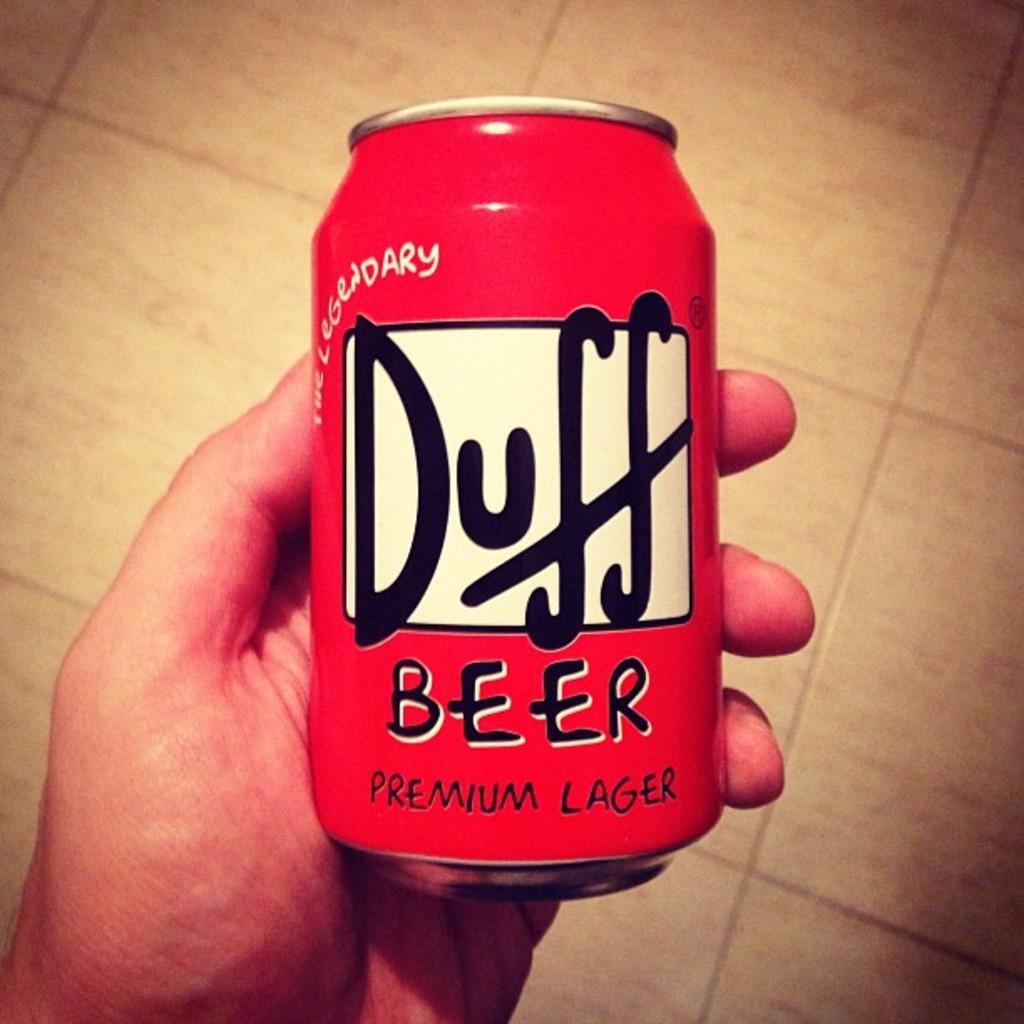What kind of beer is it?
Provide a short and direct response. Duff. 